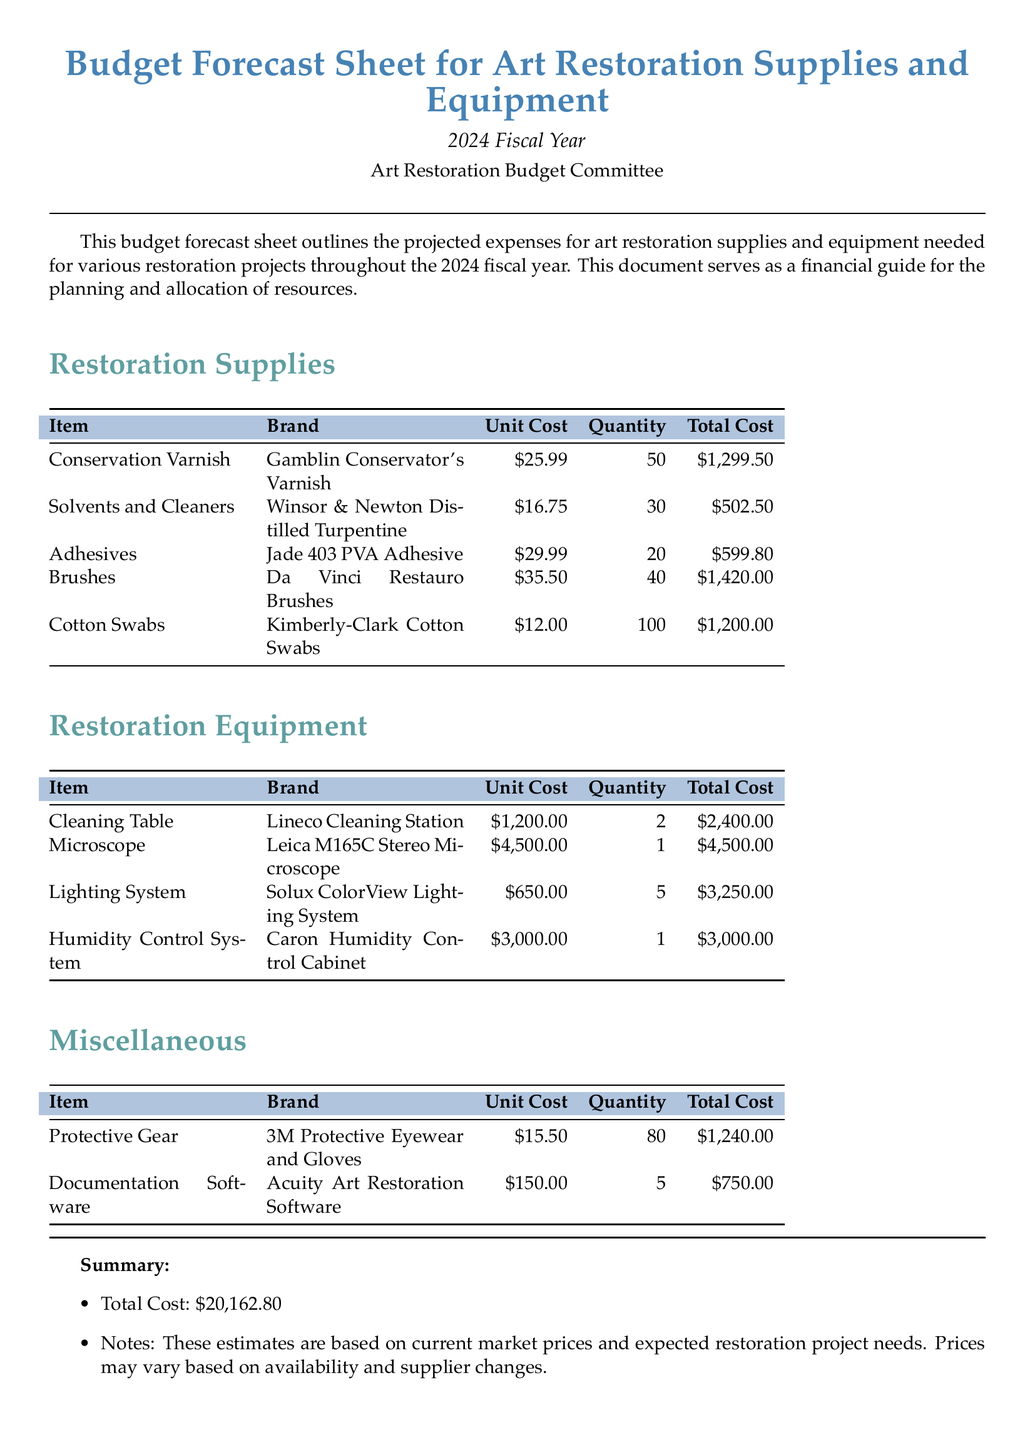What is the total cost of brushes? The total cost of brushes is found in the restoration supplies table, which shows that 40 brushes cost $35.50 each, totaling $1,420.00.
Answer: $1,420.00 How many cleaning tables are included in the budget? The restoration equipment section lists the cleaning tables with a quantity of 2.
Answer: 2 What is the unit cost of adhesives? The restoration supplies table indicates that jade 403 PVA adhesive has a unit cost of $29.99.
Answer: $29.99 What is the total budget forecast for 2024? The summary section at the end of the document states the total cost for all items is $20,162.80.
Answer: $20,162.80 Which company produces the microscope? The restoration equipment table mentions that the microscope is a Leica M165C Stereo Microscope.
Answer: Leica What is the total quantity of cotton swabs? The restoration supplies table shows that 100 cotton swabs are listed as quantity.
Answer: 100 What item has the highest unit cost? The restoration equipment section shows the microscope as the most expensive item at $4,500.00.
Answer: $4,500.00 How many items fall under the miscellaneous category? The miscellaneous section lists two items: protective gear and documentation software.
Answer: 2 What is the purpose of this budget forecast sheet? The document states that it outlines projected expenses for art restoration supplies and equipment needed for various restoration projects.
Answer: Projected expenses for art restoration supplies and equipment 